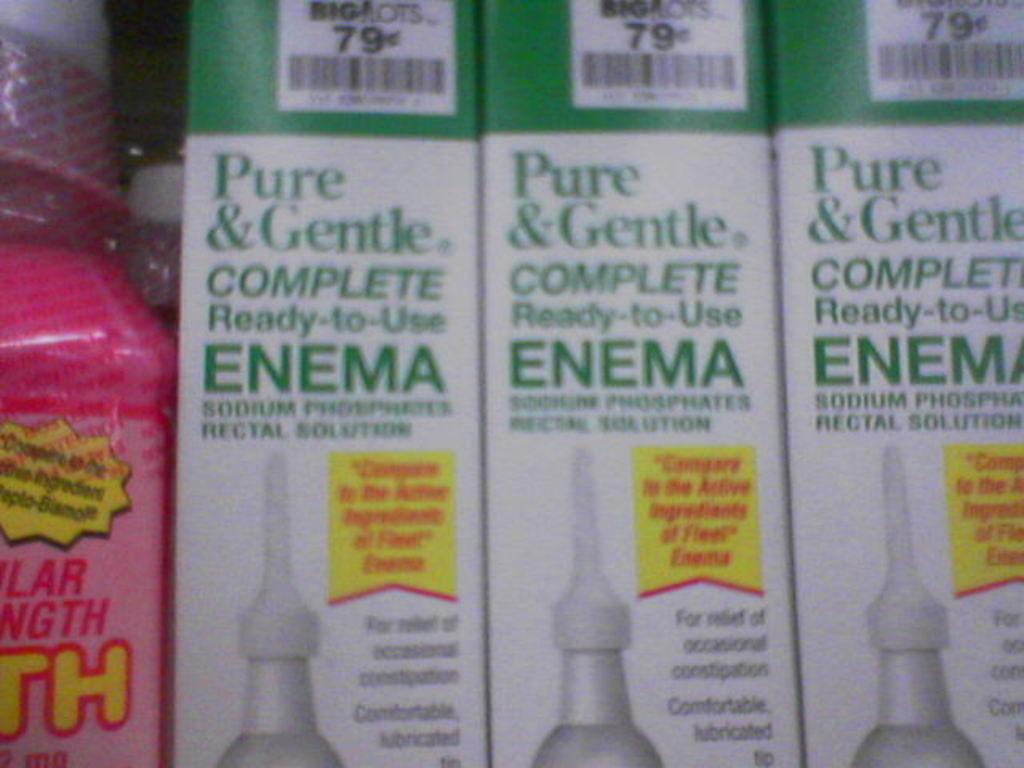What is in the boxes?
Offer a very short reply. Enema. How much does the enema cost?
Your answer should be compact. 79 cents. 